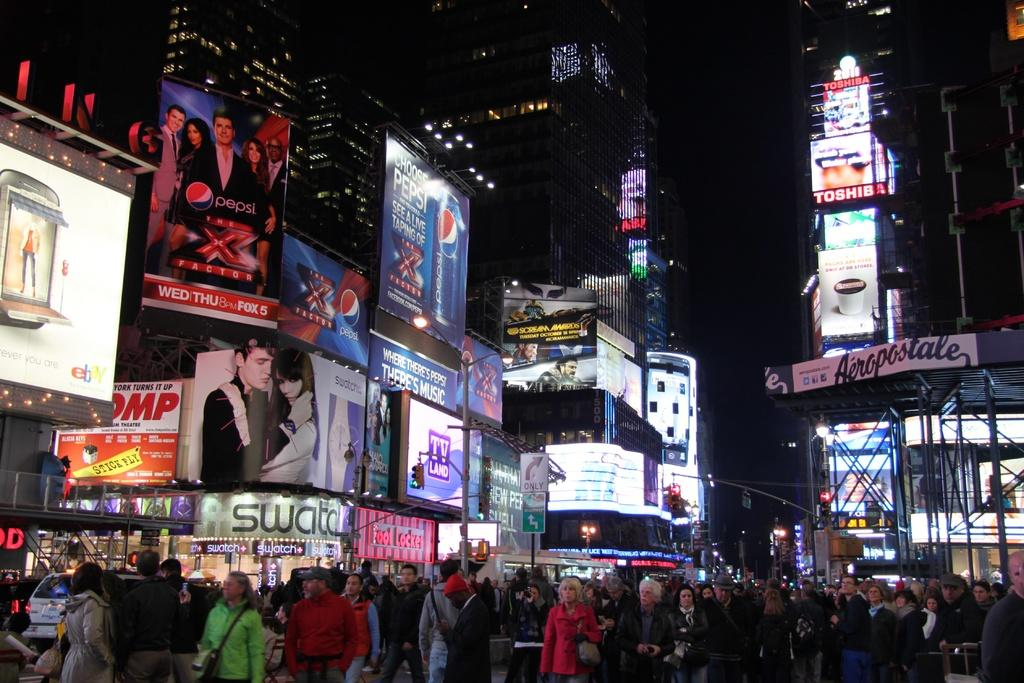<image>
Write a terse but informative summary of the picture. The "Pepsi" poster ad is attached to the building. 